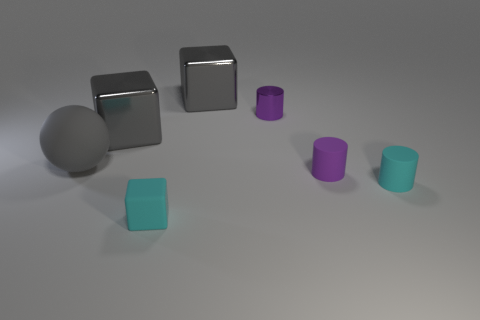Add 3 large gray cubes. How many objects exist? 10 Subtract all spheres. How many objects are left? 6 Add 1 tiny cyan rubber things. How many tiny cyan rubber things exist? 3 Subtract 0 green balls. How many objects are left? 7 Subtract all small brown blocks. Subtract all gray matte spheres. How many objects are left? 6 Add 4 tiny rubber objects. How many tiny rubber objects are left? 7 